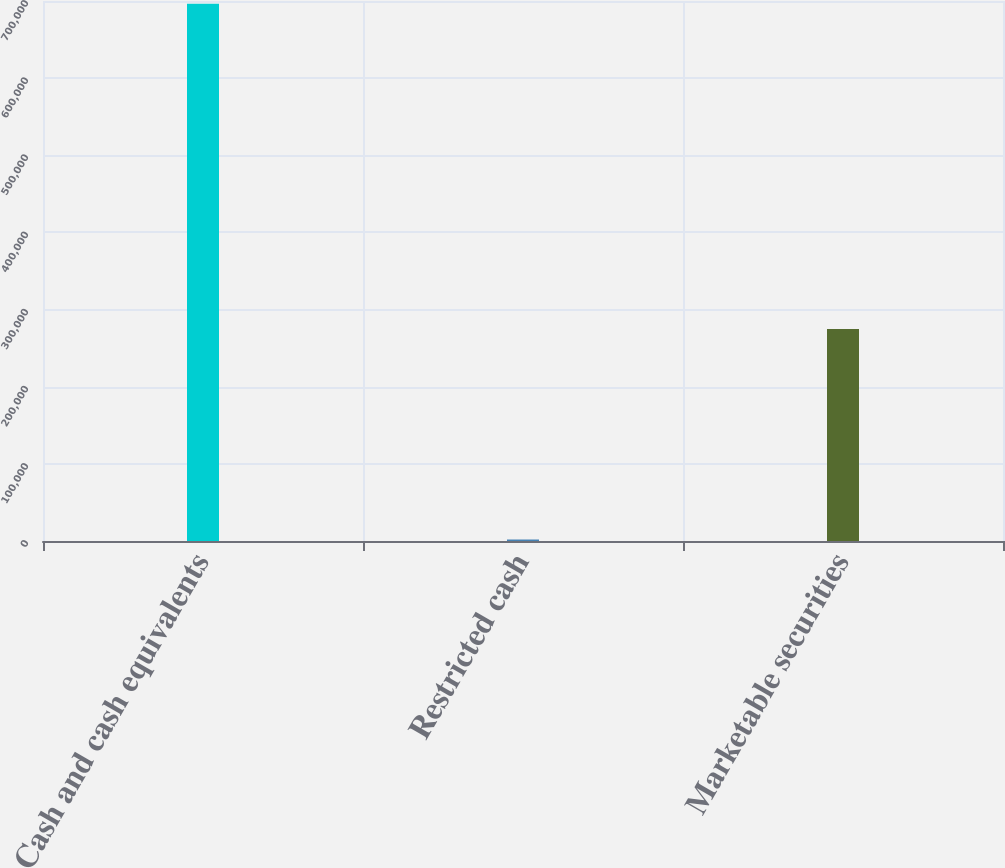<chart> <loc_0><loc_0><loc_500><loc_500><bar_chart><fcel>Cash and cash equivalents<fcel>Restricted cash<fcel>Marketable securities<nl><fcel>696335<fcel>1941<fcel>274895<nl></chart> 